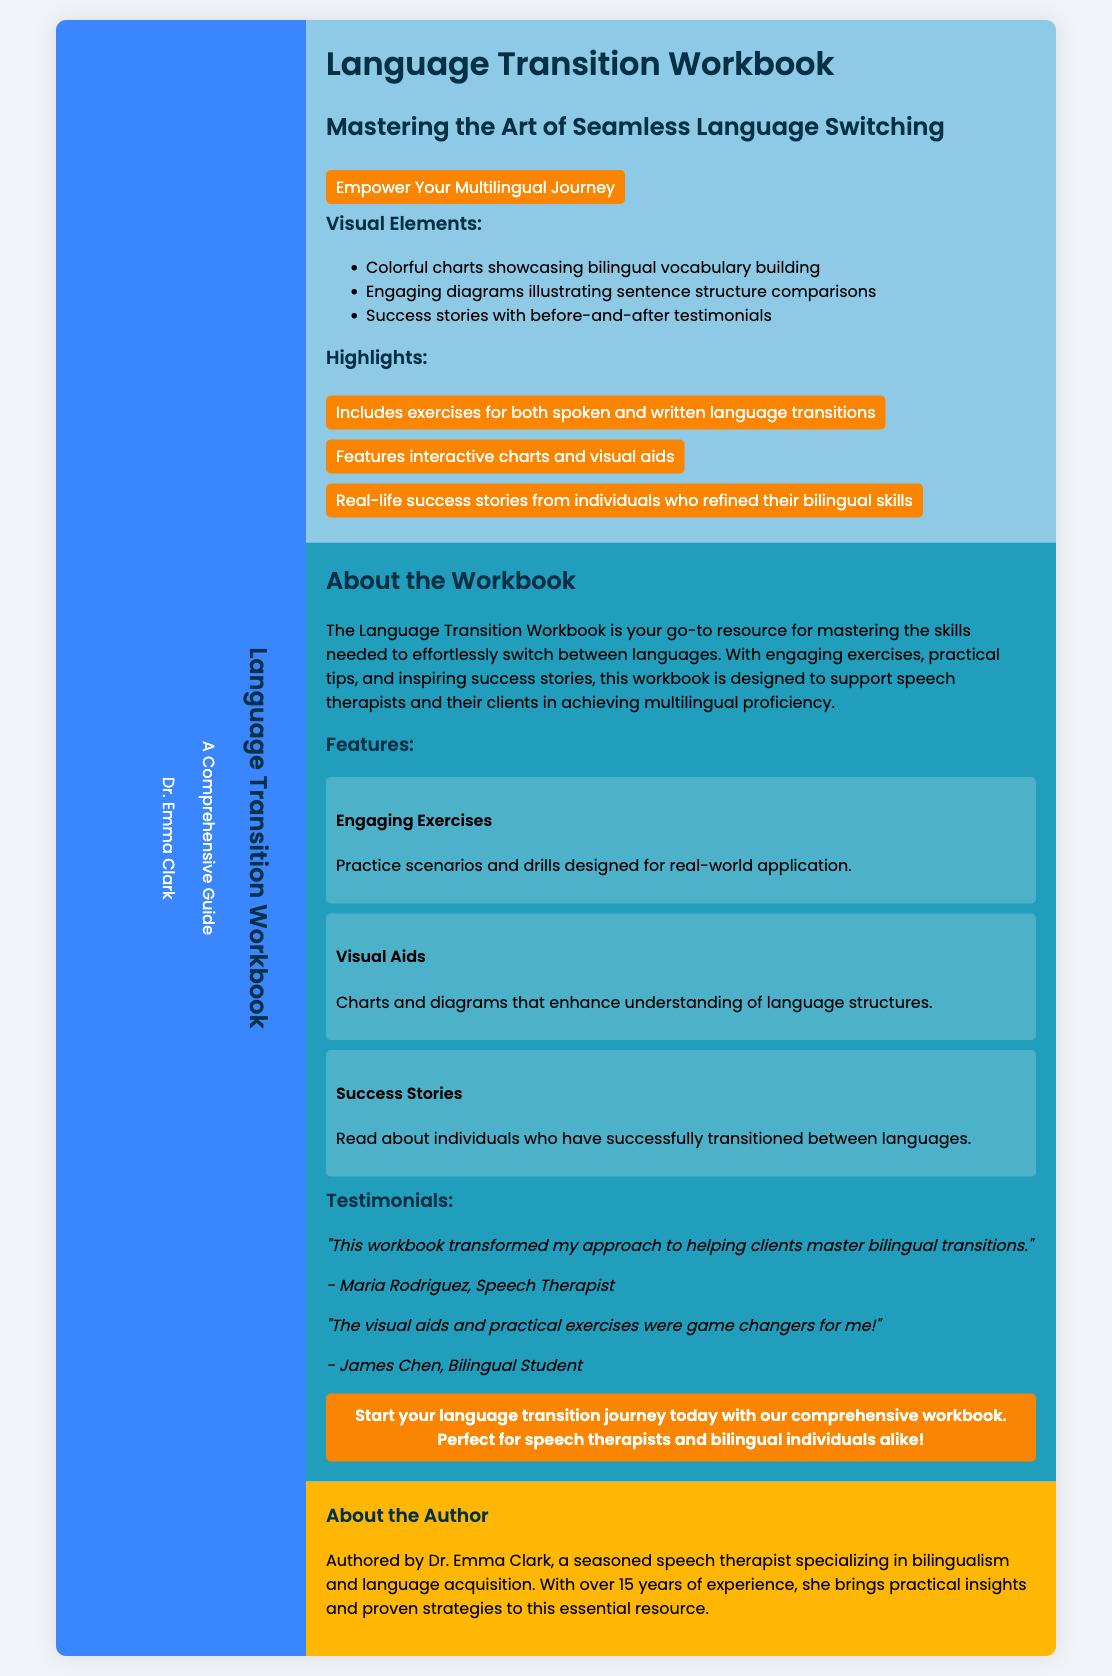What is the title of the workbook? The title of the workbook is prominently displayed on the front cover of the document.
Answer: Language Transition Workbook Who is the author of the workbook? The author’s name is mentioned on the spine of the document.
Answer: Dr. Emma Clark What color is the spine of the workbook? The color of the spine is specified in the design section of the document.
Answer: Blue What is a feature highlighted in the workbook? Features are listed in the back cover section of the document, showcasing its offerings.
Answer: Engaging Exercises How many success stories are featured in the workbook? The workbook includes real-life success stories as stated in multiple sections of the document.
Answer: Several What is one type of visual aid mentioned? Visual aids are listed in the highlights and features sections of the document.
Answer: Charts Who provided a testimonial about the workbook? The testimonials are attributed to specific individuals listed in the back cover section.
Answer: Maria Rodriguez What is the primary audience for this workbook? The intended audience is described in the call to action and overview sections of the document.
Answer: Speech therapists What is the background of the author? The author's qualifications and experience are summarized in the inside flap section of the document.
Answer: Speech therapist specializing in bilingualism 